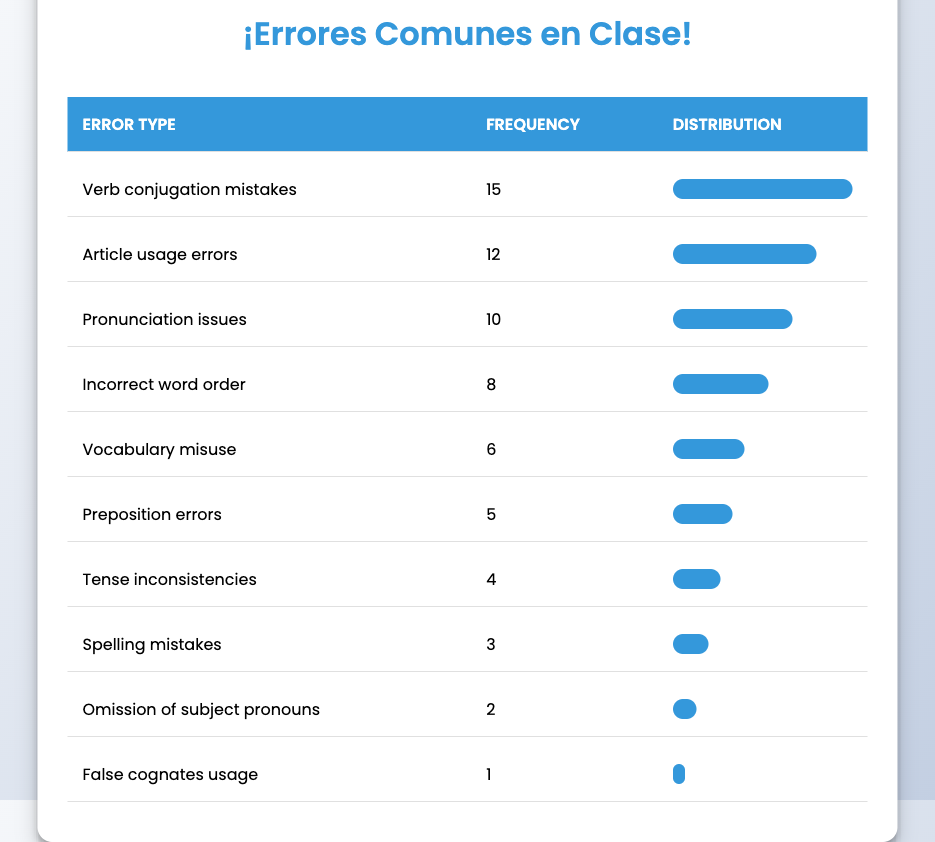What is the most frequent type of language error? The table lists different types of language errors along with their frequencies. The highest frequency is associated with "Verb conjugation mistakes," which has a frequency of 15.
Answer: Verb conjugation mistakes How many students made "Article usage errors"? In the table, "Article usage errors" has a frequency of 12, indicating that 12 students made this type of error.
Answer: 12 What is the total frequency of the top three types of language errors? To find the total, I will sum the frequencies of the top three error types: 15 (Verb conjugation mistakes) + 12 (Article usage errors) + 10 (Pronunciation issues) = 37.
Answer: 37 Are "Spelling mistakes" more frequent than "False cognates usage"? "Spelling mistakes" has a frequency of 3, while "False cognates usage" has a frequency of 1. Since 3 is greater than 1, it confirms that spelling mistakes are indeed more frequent.
Answer: Yes What is the average frequency of the language errors listed? To calculate the average frequency, I will first sum all the frequencies: 15 + 12 + 10 + 8 + 6 + 5 + 4 + 3 + 2 + 1 = 66. There are 10 error types, so the average is 66 divided by 10, which equals 6.6.
Answer: 6.6 Which errors have a frequency less than 5? I will check the table for errors with frequencies below 5. The frequencies below 5 are 4 (Tense inconsistencies), 3 (Spelling mistakes), 2 (Omission of subject pronouns), and 1 (False cognates usage). This shows there are four errors in total.
Answer: Four errors If we combine the frequencies of "Preposition errors" and "Vocabulary misuse," what is the result? "Preposition errors" has a frequency of 5, and "Vocabulary misuse" has a frequency of 6. Adding these together, 5 + 6 = 11.
Answer: 11 What percentage of errors are "Pronunciation issues"? "Pronunciation issues" has a frequency of 10. To find its percentage, I first calculate the total frequency, which is 66. Then I divide 10 by 66 and multiply by 100, resulting in approximately 15.15%.
Answer: Approximately 15.15% 